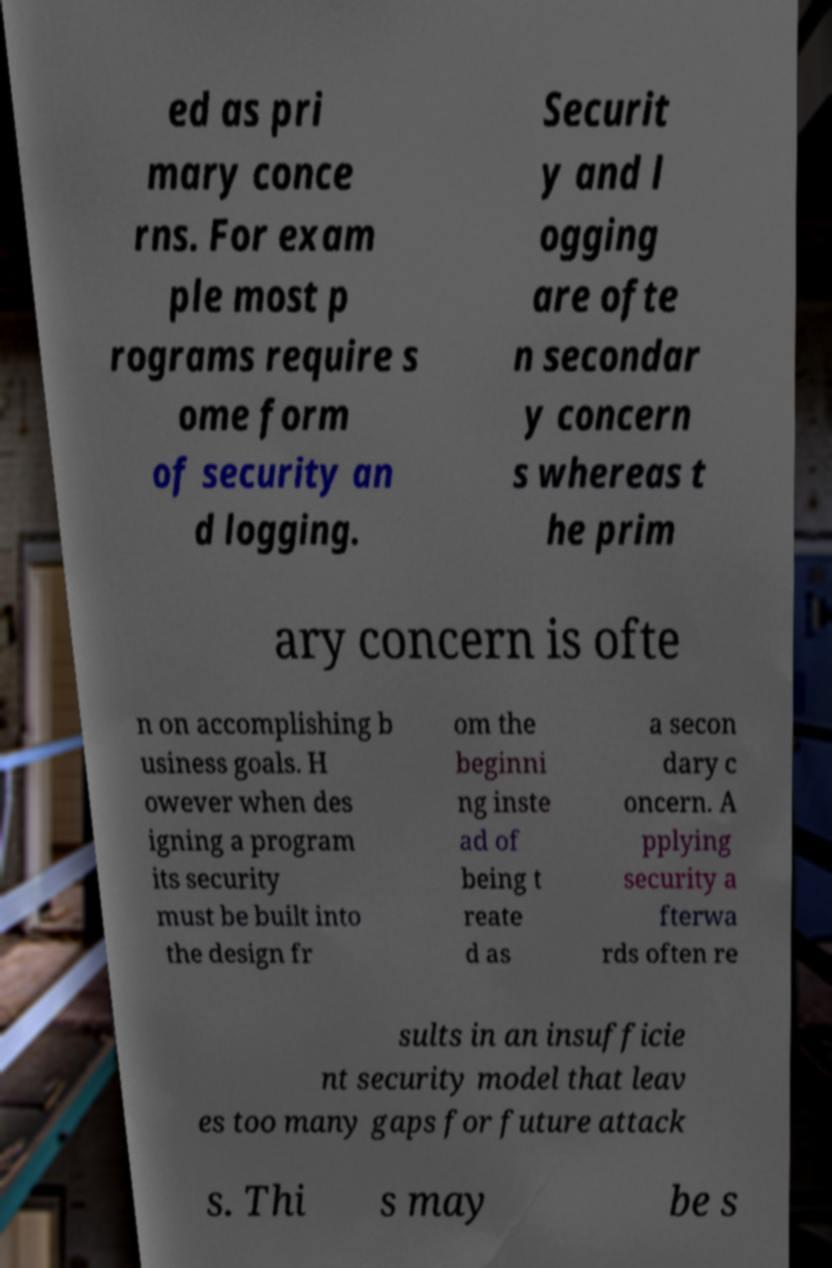I need the written content from this picture converted into text. Can you do that? ed as pri mary conce rns. For exam ple most p rograms require s ome form of security an d logging. Securit y and l ogging are ofte n secondar y concern s whereas t he prim ary concern is ofte n on accomplishing b usiness goals. H owever when des igning a program its security must be built into the design fr om the beginni ng inste ad of being t reate d as a secon dary c oncern. A pplying security a fterwa rds often re sults in an insufficie nt security model that leav es too many gaps for future attack s. Thi s may be s 